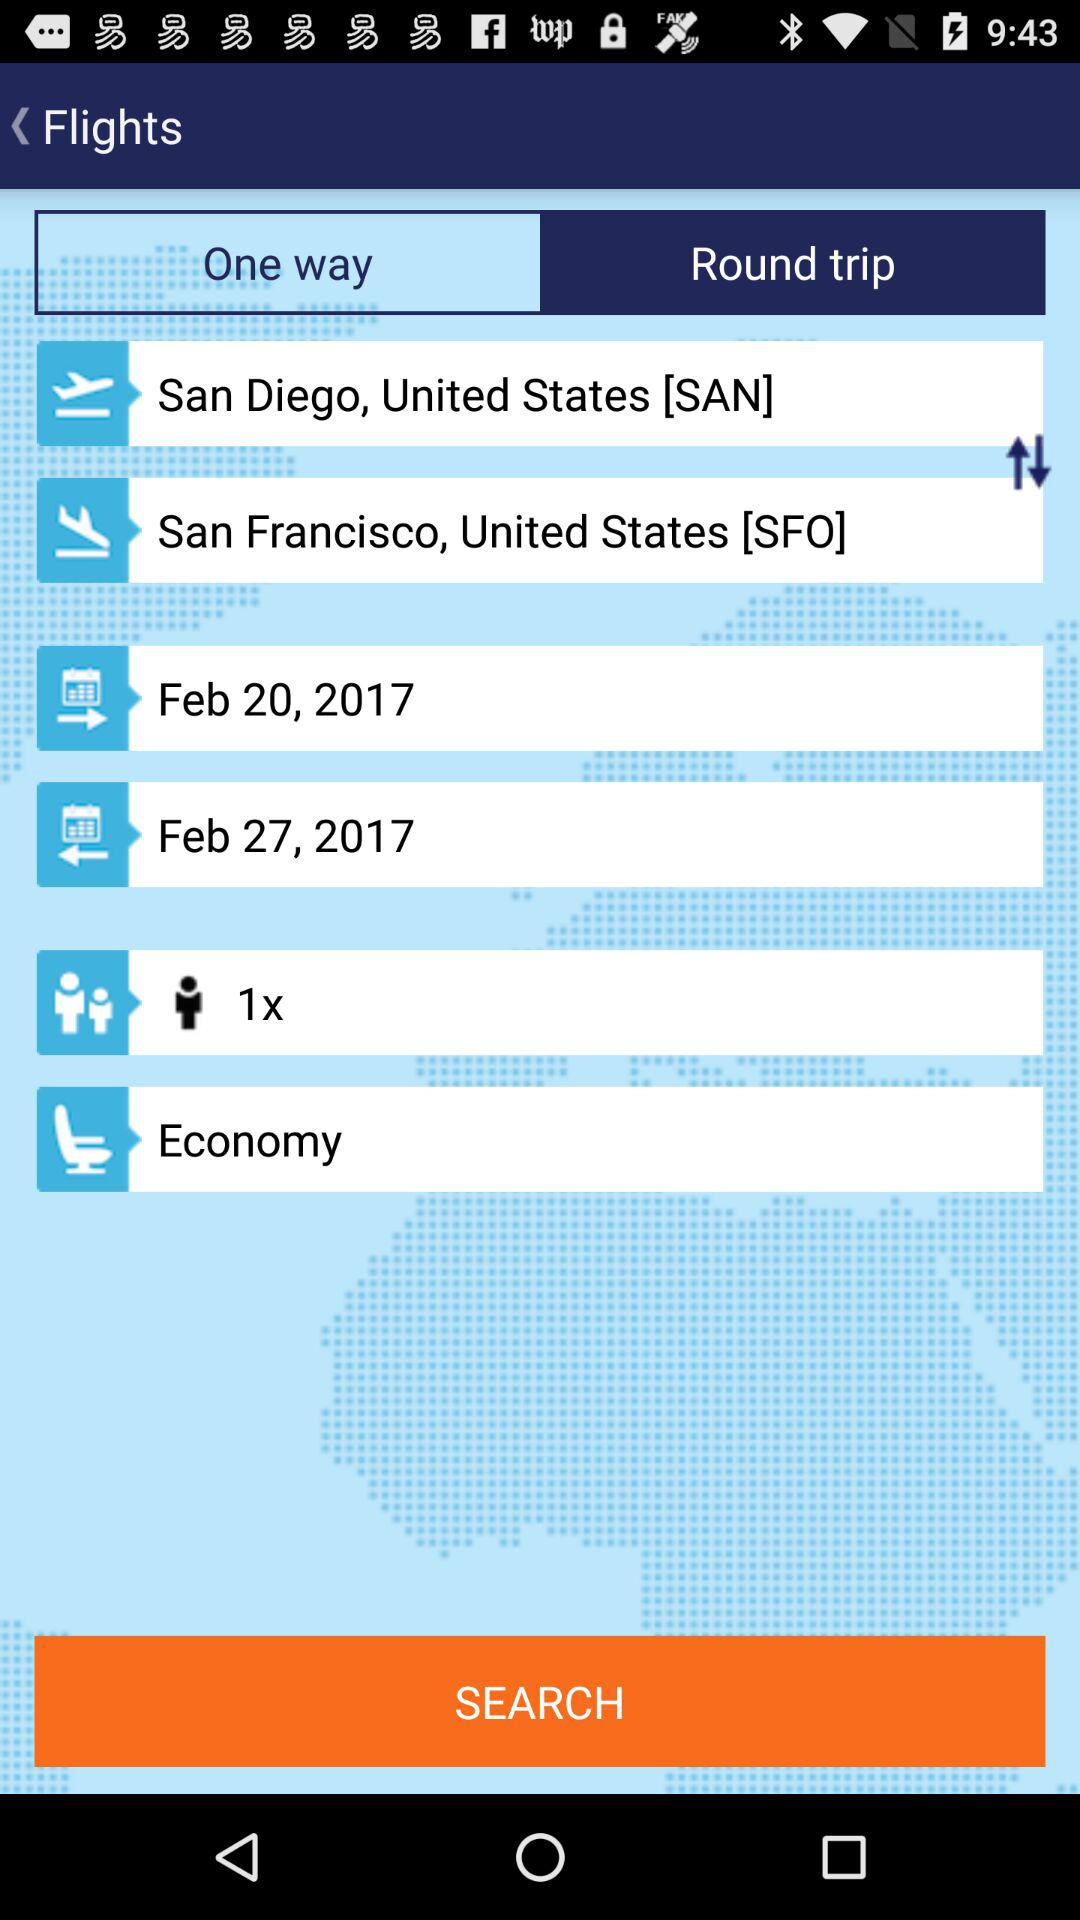What class of ticket is booked? The class of ticket is economy. 